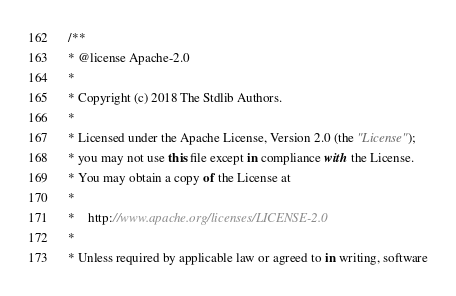Convert code to text. <code><loc_0><loc_0><loc_500><loc_500><_JavaScript_>/**
* @license Apache-2.0
*
* Copyright (c) 2018 The Stdlib Authors.
*
* Licensed under the Apache License, Version 2.0 (the "License");
* you may not use this file except in compliance with the License.
* You may obtain a copy of the License at
*
*    http://www.apache.org/licenses/LICENSE-2.0
*
* Unless required by applicable law or agreed to in writing, software</code> 